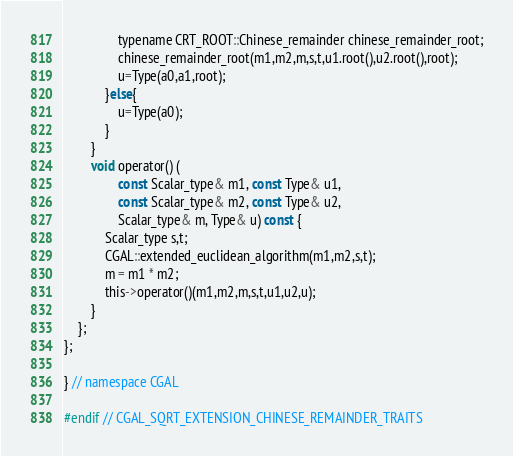Convert code to text. <code><loc_0><loc_0><loc_500><loc_500><_C_>                typename CRT_ROOT::Chinese_remainder chinese_remainder_root;
                chinese_remainder_root(m1,m2,m,s,t,u1.root(),u2.root(),root);
                u=Type(a0,a1,root);
            }else{
                u=Type(a0);
            }
        }
        void operator() (
                const Scalar_type& m1, const Type& u1,
                const Scalar_type& m2, const Type& u2,
                Scalar_type& m, Type& u) const {
            Scalar_type s,t; 
            CGAL::extended_euclidean_algorithm(m1,m2,s,t);
            m = m1 * m2;
            this->operator()(m1,m2,m,s,t,u1,u2,u);
        }
    };
};

} // namespace CGAL 

#endif // CGAL_SQRT_EXTENSION_CHINESE_REMAINDER_TRAITS
</code> 